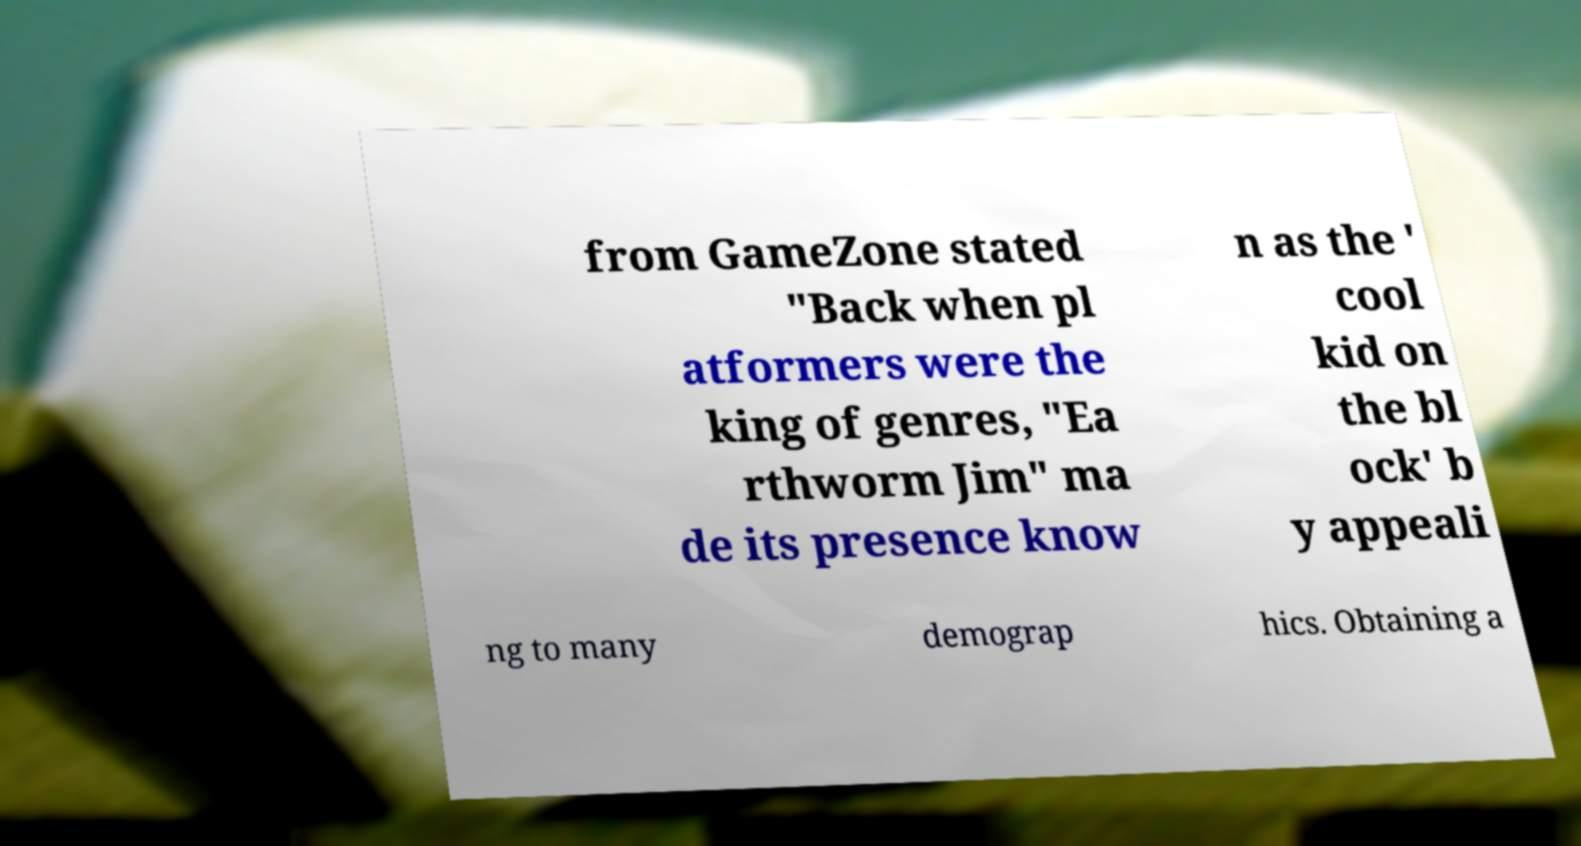Could you assist in decoding the text presented in this image and type it out clearly? from GameZone stated "Back when pl atformers were the king of genres, "Ea rthworm Jim" ma de its presence know n as the ' cool kid on the bl ock' b y appeali ng to many demograp hics. Obtaining a 